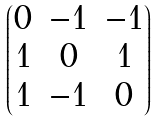<formula> <loc_0><loc_0><loc_500><loc_500>\begin{pmatrix} 0 & - 1 & - 1 \\ 1 & 0 & 1 \\ 1 & - 1 & 0 \end{pmatrix}</formula> 